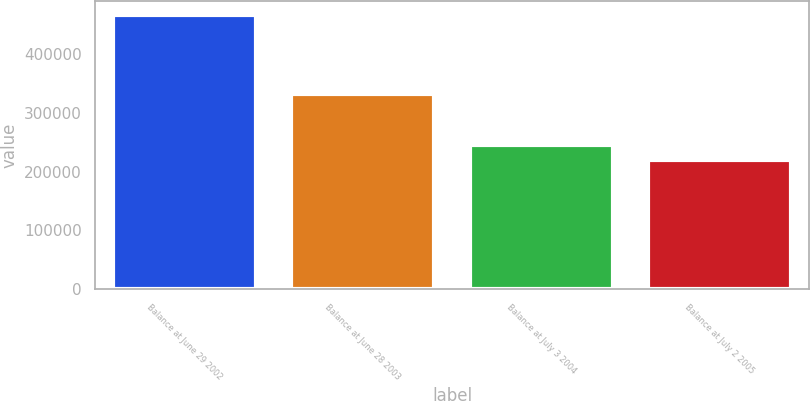Convert chart. <chart><loc_0><loc_0><loc_500><loc_500><bar_chart><fcel>Balance at June 29 2002<fcel>Balance at June 28 2003<fcel>Balance at July 3 2004<fcel>Balance at July 2 2005<nl><fcel>466719<fcel>332468<fcel>244955<fcel>220315<nl></chart> 